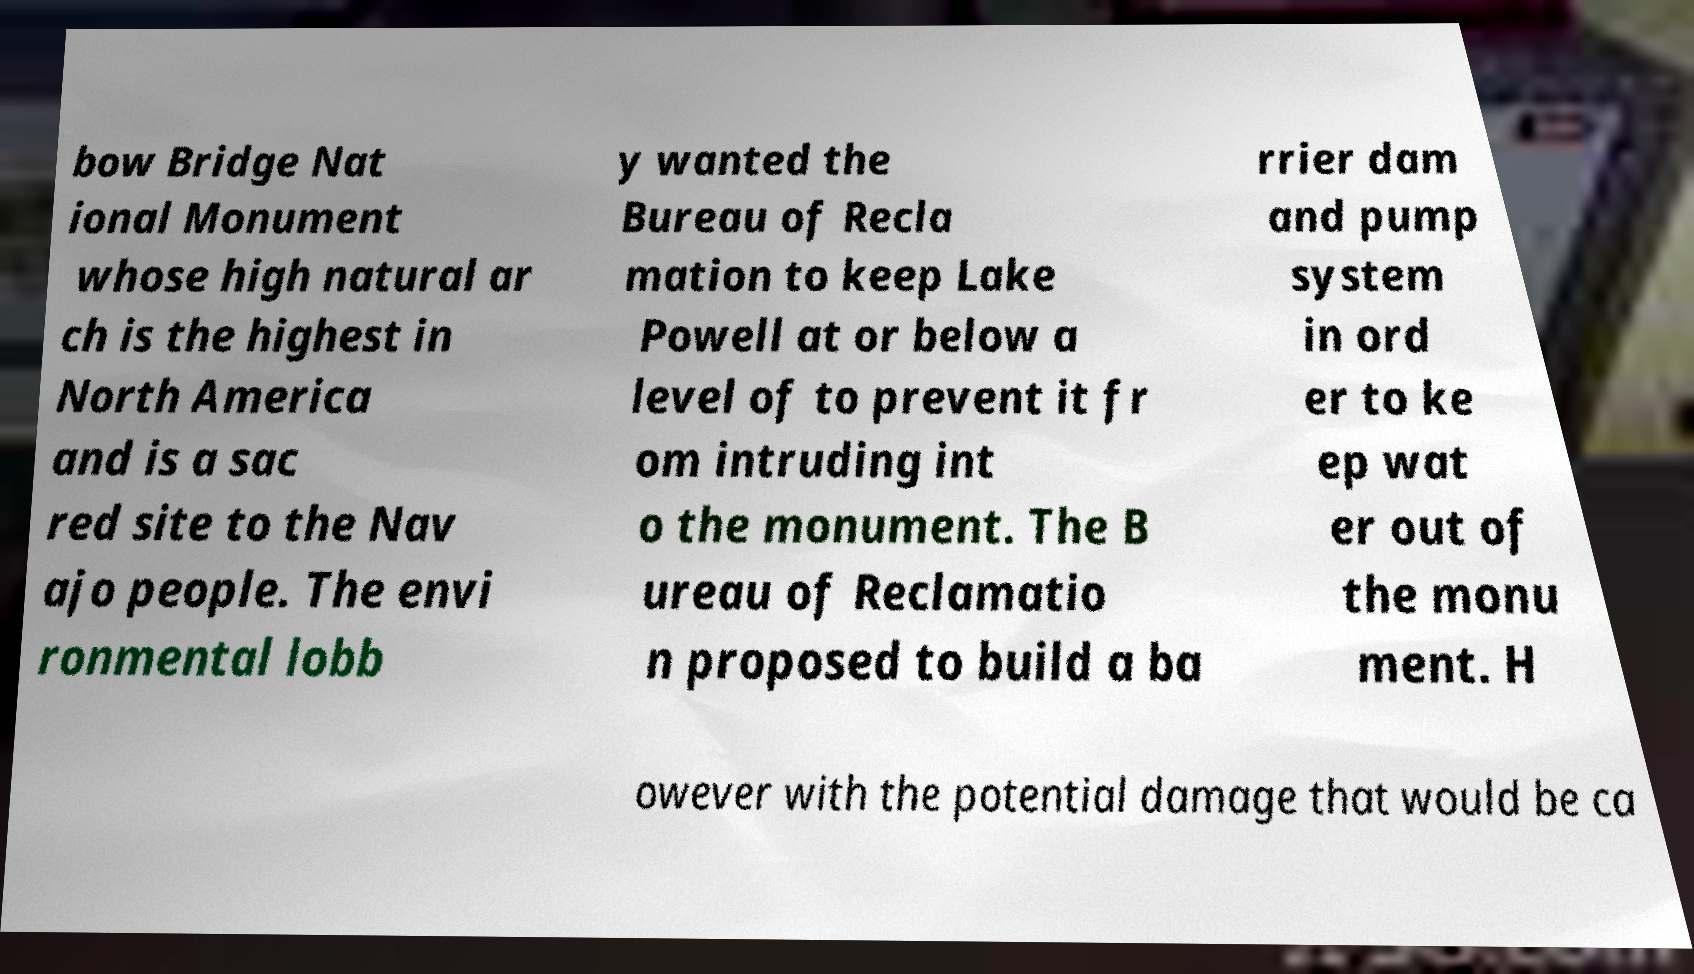Could you assist in decoding the text presented in this image and type it out clearly? bow Bridge Nat ional Monument whose high natural ar ch is the highest in North America and is a sac red site to the Nav ajo people. The envi ronmental lobb y wanted the Bureau of Recla mation to keep Lake Powell at or below a level of to prevent it fr om intruding int o the monument. The B ureau of Reclamatio n proposed to build a ba rrier dam and pump system in ord er to ke ep wat er out of the monu ment. H owever with the potential damage that would be ca 